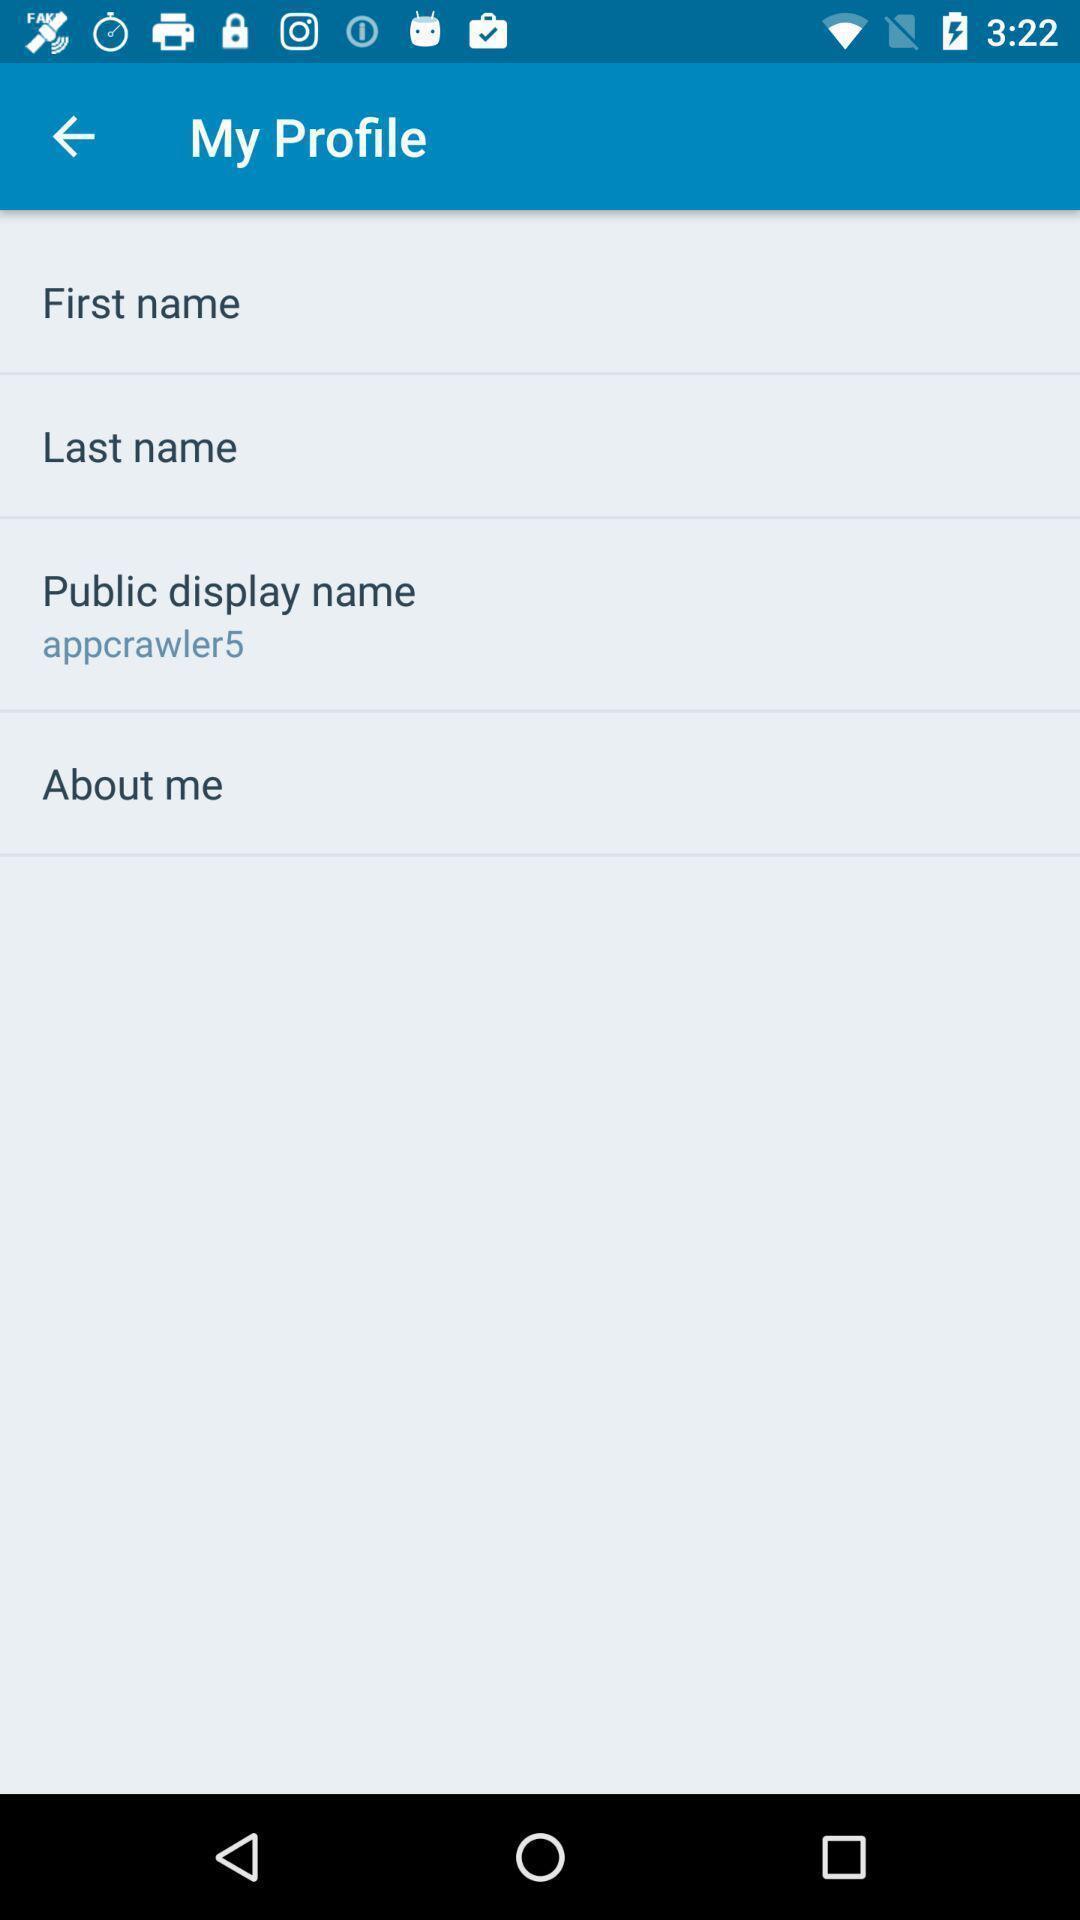Tell me what you see in this picture. Page showing the input fields for profile details. 